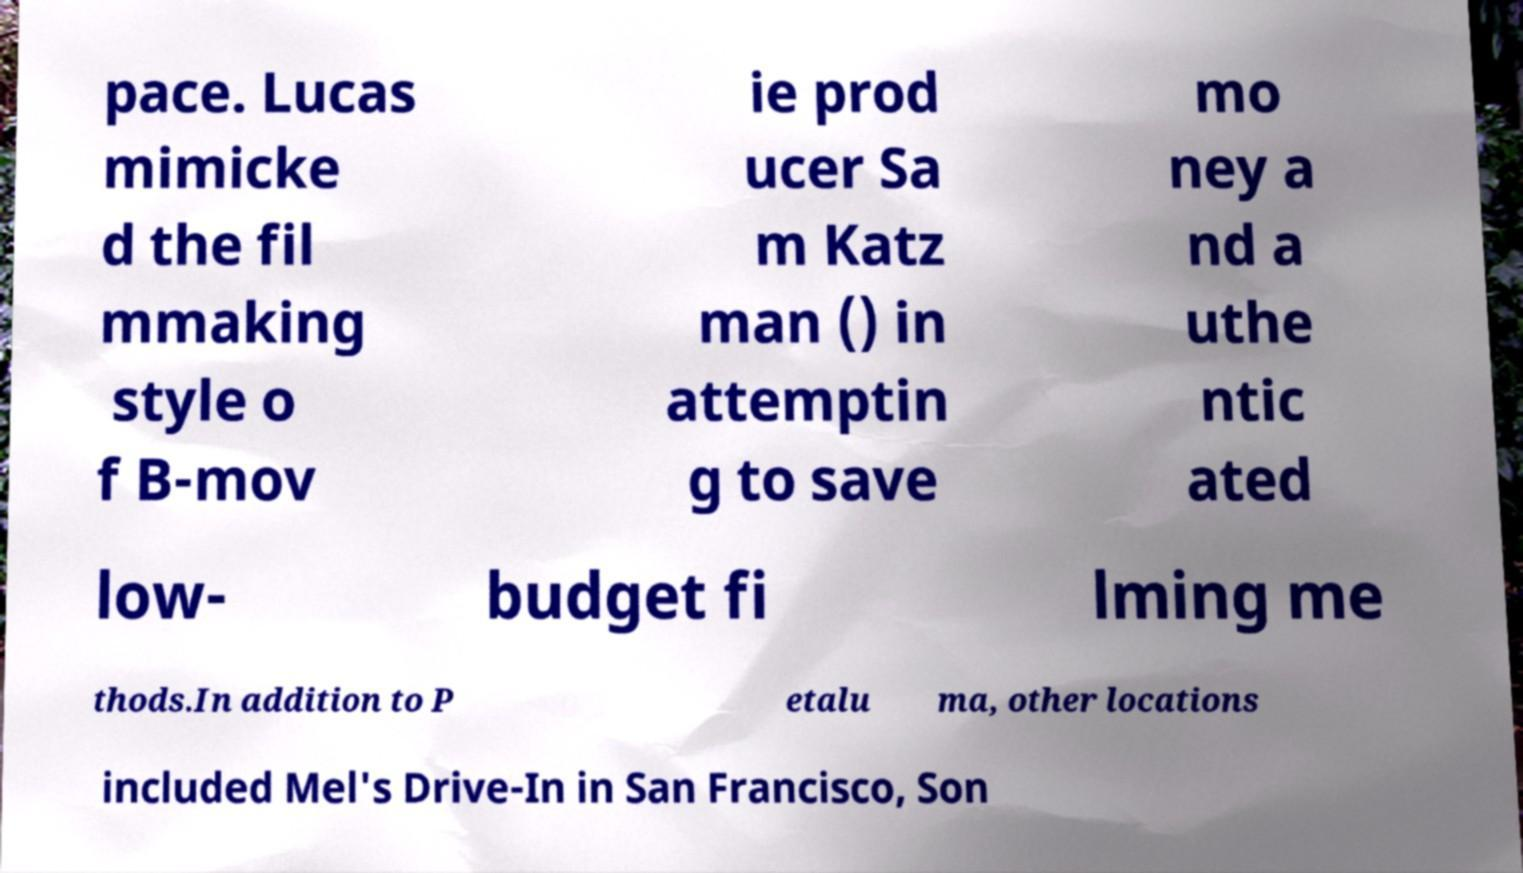Please read and relay the text visible in this image. What does it say? pace. Lucas mimicke d the fil mmaking style o f B-mov ie prod ucer Sa m Katz man () in attemptin g to save mo ney a nd a uthe ntic ated low- budget fi lming me thods.In addition to P etalu ma, other locations included Mel's Drive-In in San Francisco, Son 